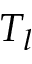Convert formula to latex. <formula><loc_0><loc_0><loc_500><loc_500>T _ { l }</formula> 